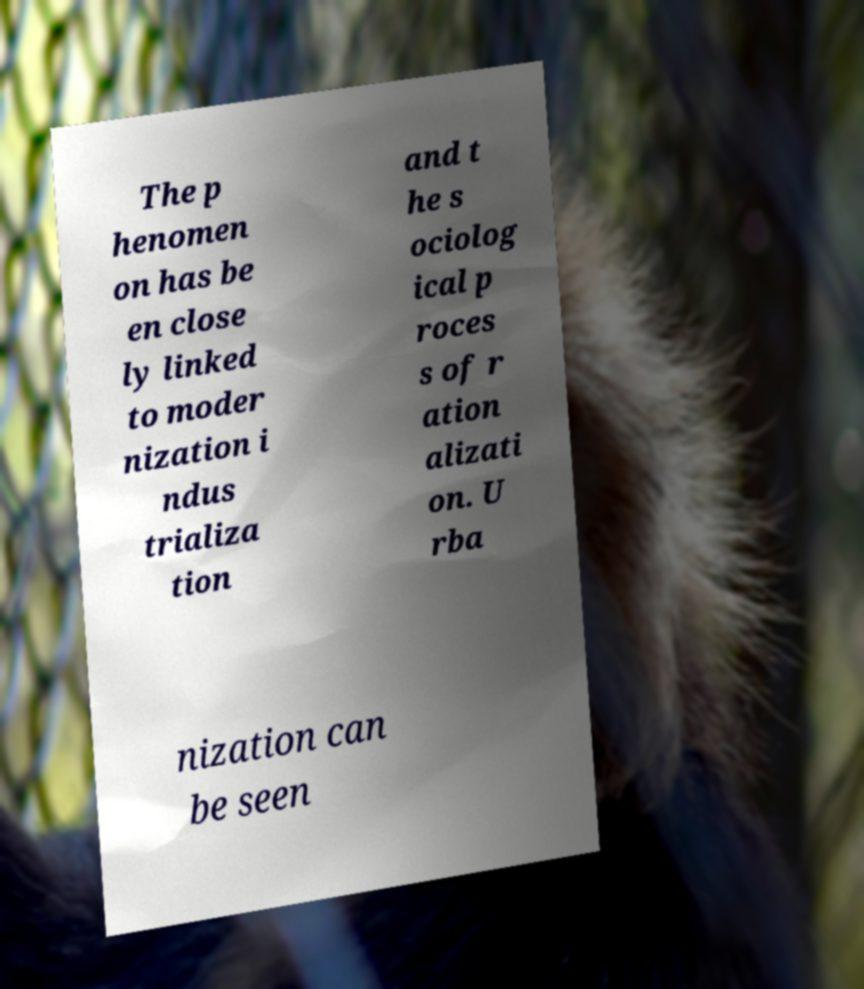I need the written content from this picture converted into text. Can you do that? The p henomen on has be en close ly linked to moder nization i ndus trializa tion and t he s ociolog ical p roces s of r ation alizati on. U rba nization can be seen 